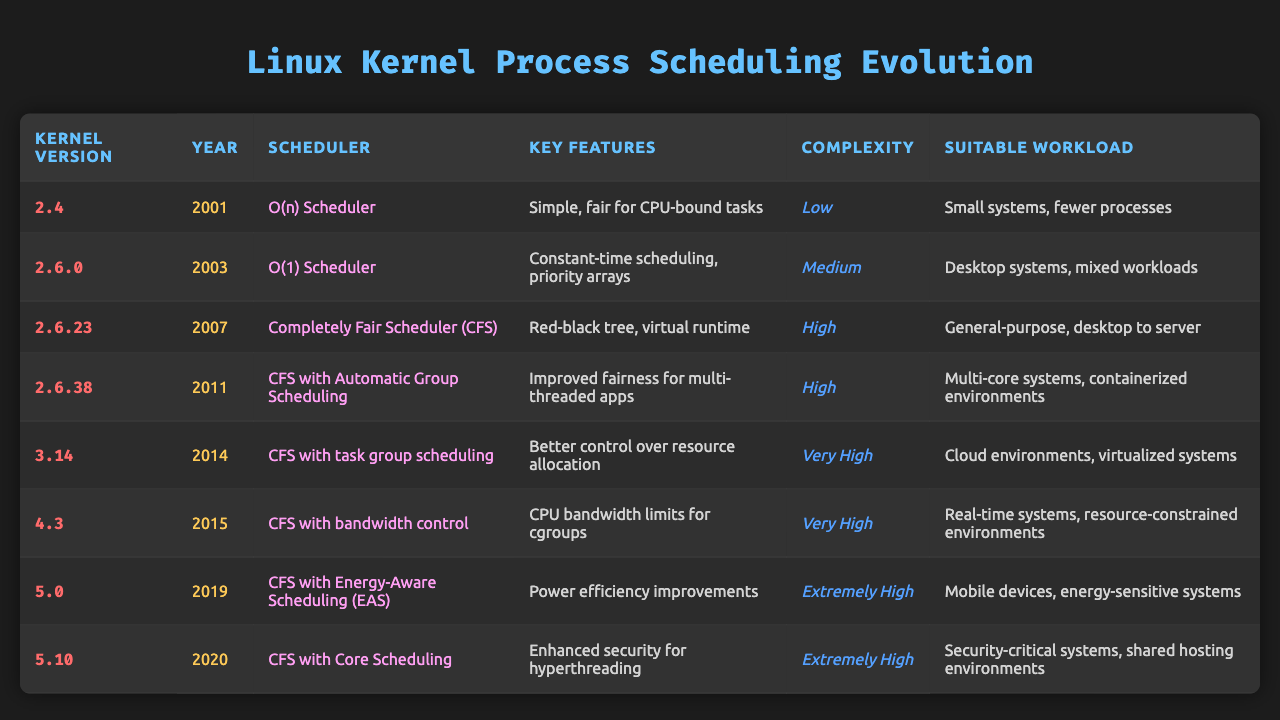What is the kernel version for the CFS with Energy-Aware Scheduling? The table indicates that the CFS with Energy-Aware Scheduling was introduced in kernel version 5.0.
Answer: 5.0 Which scheduler was introduced in 2003? According to the table, the O(1) Scheduler was introduced in the year 2003.
Answer: O(1) Scheduler In which kernel version did CFS with task group scheduling appear? The table shows that CFS with task group scheduling was introduced in kernel version 3.14.
Answer: 3.14 What is the key feature of the Completely Fair Scheduler? The key feature of the Completely Fair Scheduler, as listed in the table, includes a red-black tree and virtual runtime.
Answer: Red-black tree, virtual runtime Which scheduling algorithm is suitable for mobile devices? The table indicates that the CFS with Energy-Aware Scheduling is suitable for mobile devices.
Answer: CFS with Energy-Aware Scheduling How many scheduling algorithms were introduced between 2001 and 2015? The table lists 7 scheduling algorithms introduced from 2001 to 2015: O(n) Scheduler (2001), O(1) Scheduler (2003), CFS (2007), CFS with Automatic Group Scheduling (2011), CFS with task group scheduling (2014), and CFS with bandwidth control (2015).
Answer: 6 Which kernel version has the highest complexity? The table shows that both the CFS with Energy-Aware Scheduling (5.0) and CFS with Core Scheduling (5.10) have the highest complexity rating of 'Extremely High.'
Answer: 5.0 and 5.10 Is the O(n) Scheduler suitable for cloud environments? The table specifies that the O(n) Scheduler is suitable for small systems with fewer processes, not cloud environments.
Answer: No What is the primary focus of CFS with bandwidth control? The primary focus of CFS with bandwidth control, as per the table, is to establish CPU bandwidth limits for cgroups.
Answer: CPU bandwidth limits for cgroups What evolution trend can be seen in process scheduling algorithms regarding workload suitability? The evolution trend indicates that as kernel versions progress, the scheduling algorithms have become more suitable for complex workloads, such as containerized environments and cloud settings.
Answer: Increased suitability for complex workloads 